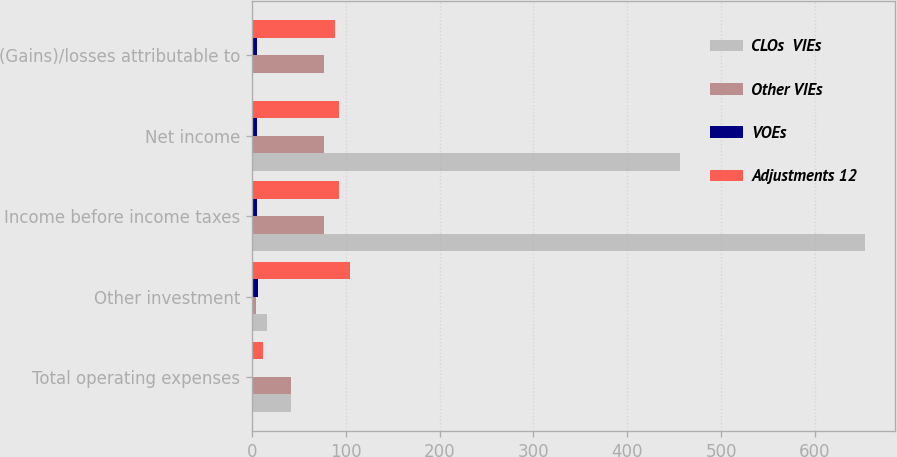Convert chart. <chart><loc_0><loc_0><loc_500><loc_500><stacked_bar_chart><ecel><fcel>Total operating expenses<fcel>Other investment<fcel>Income before income taxes<fcel>Net income<fcel>(Gains)/losses attributable to<nl><fcel>CLOs  VIEs<fcel>41.4<fcel>15.6<fcel>653.1<fcel>456.1<fcel>0.2<nl><fcel>Other VIEs<fcel>41.4<fcel>3.8<fcel>77.1<fcel>77.1<fcel>77.1<nl><fcel>VOEs<fcel>1.6<fcel>6.9<fcel>5.3<fcel>5.3<fcel>5.3<nl><fcel>Adjustments 12<fcel>12.3<fcel>104.5<fcel>92.5<fcel>92.5<fcel>88.4<nl></chart> 